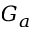Convert formula to latex. <formula><loc_0><loc_0><loc_500><loc_500>G _ { a }</formula> 